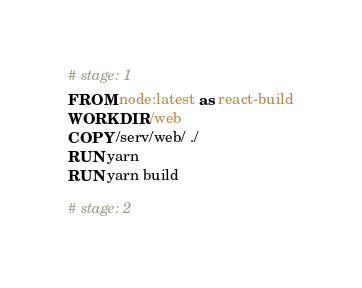<code> <loc_0><loc_0><loc_500><loc_500><_Dockerfile_># stage: 1
FROM node:latest as react-build
WORKDIR /web
COPY /serv/web/ ./
RUN yarn
RUN yarn build

# stage: 2</code> 